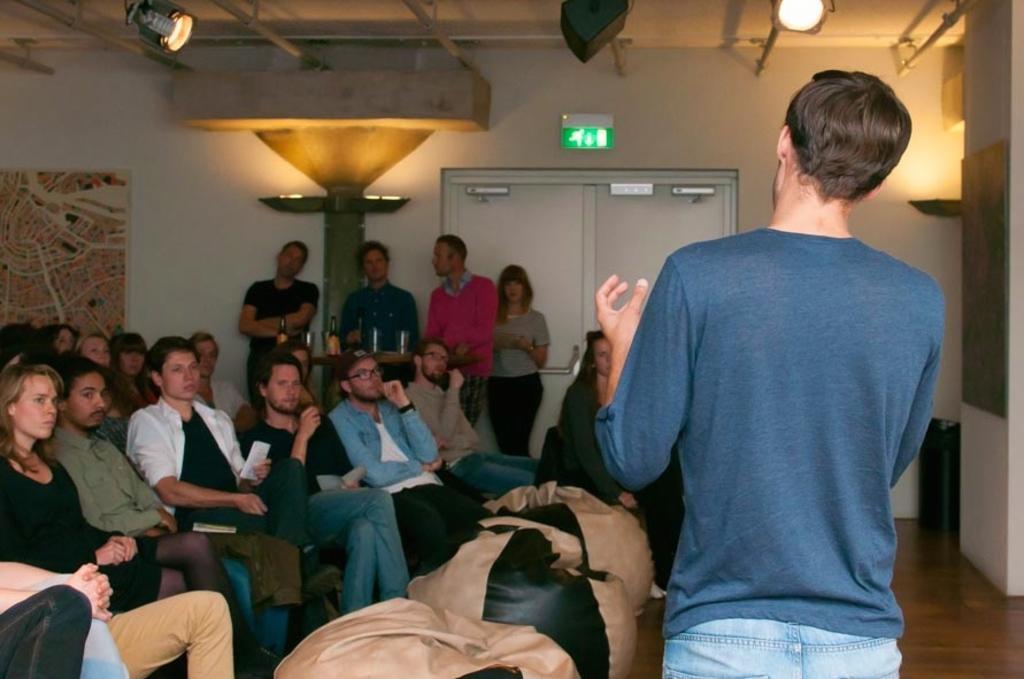Describe this image in one or two sentences. On the right side, there is a person in a T-shirt, standing. On the left side, there are persons in different color dresses sitting. In the background, there are persons standing, there are lights attached to the roof and there is a white wall. 